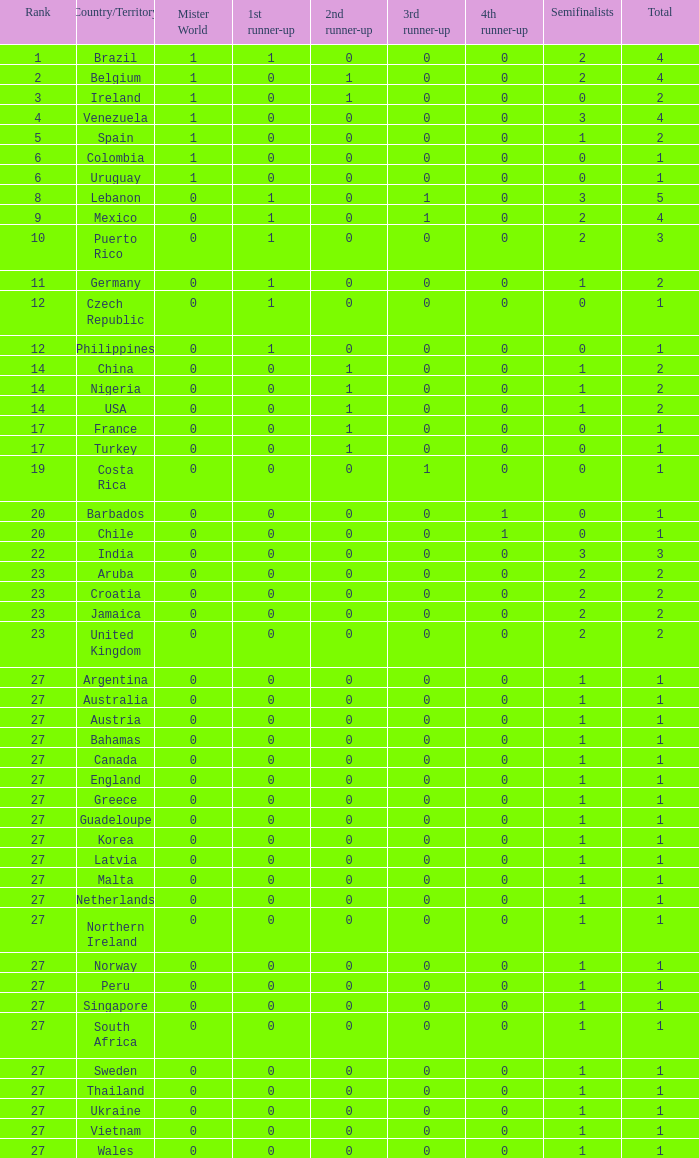What is the minimum value for the 1st runner up? 0.0. 